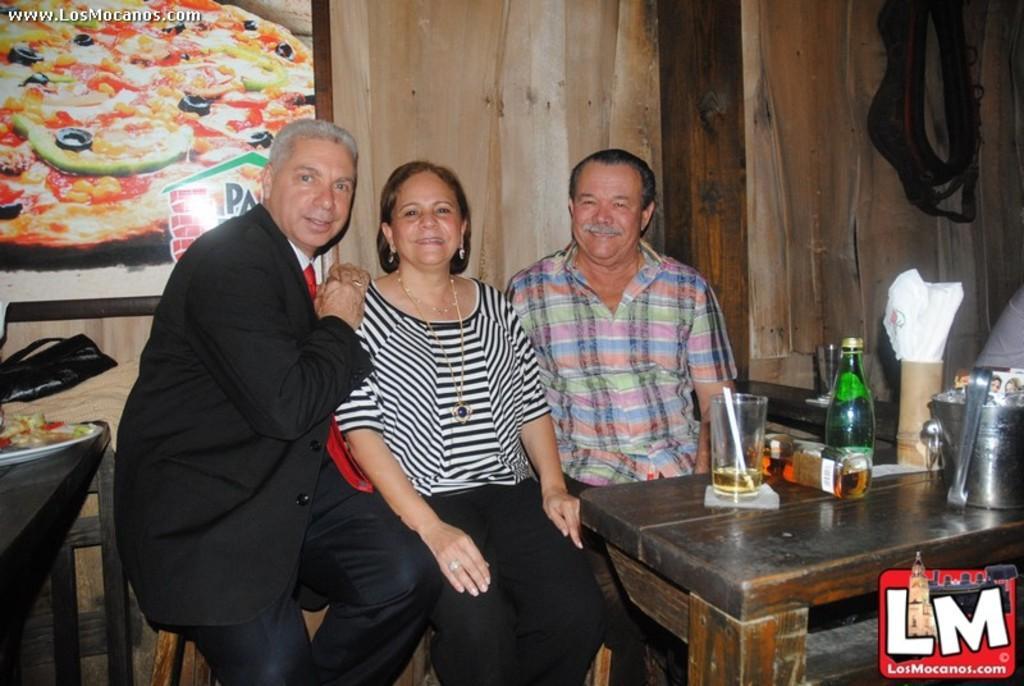In one or two sentences, can you explain what this image depicts? The two men's sitting on the either side of an women and there is a table in front of them, Which contains two bottles and a glass with a drink in it. 